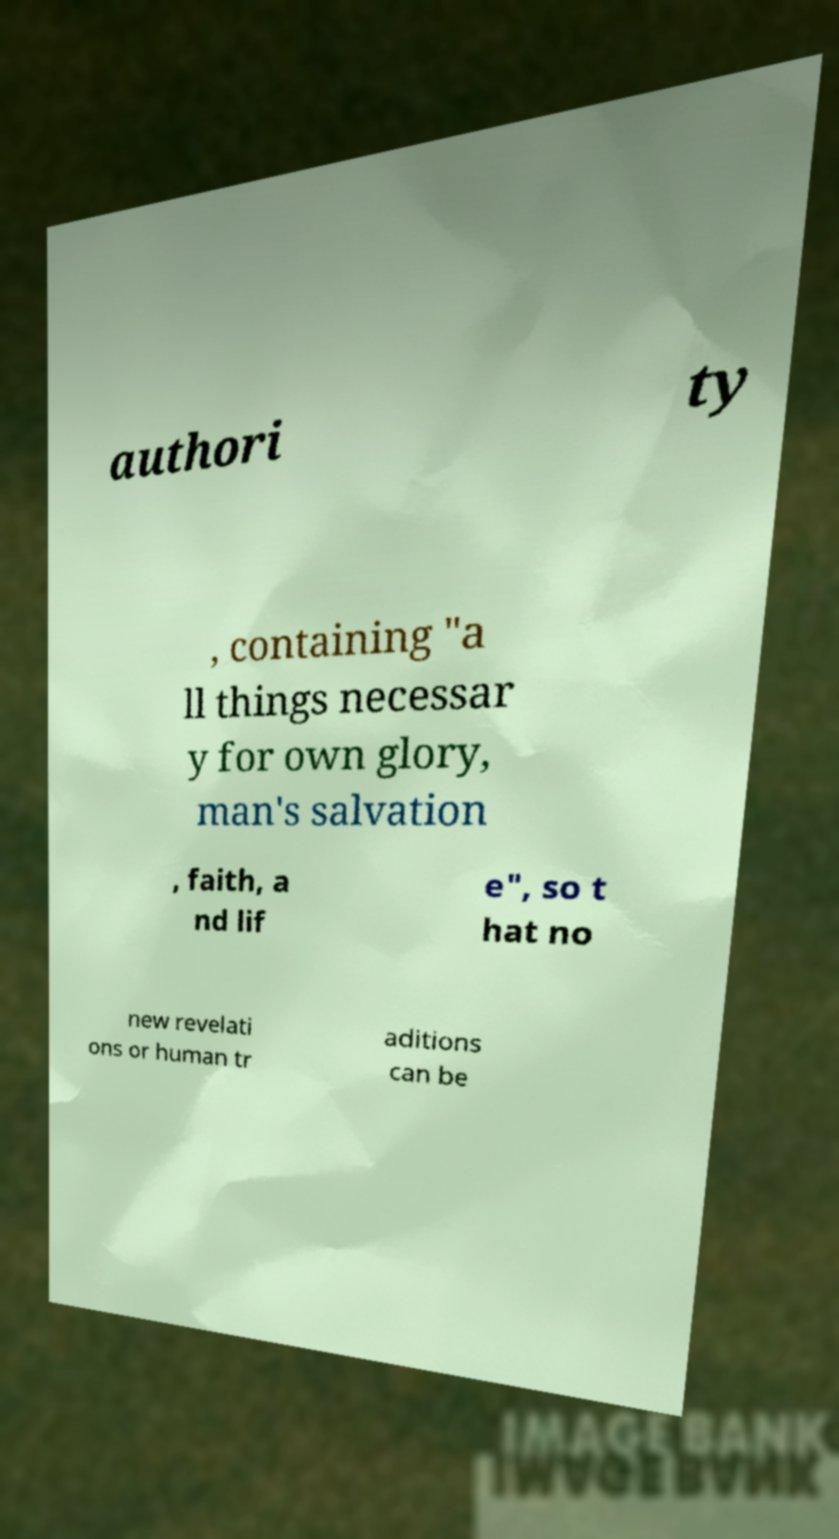Could you assist in decoding the text presented in this image and type it out clearly? authori ty , containing "a ll things necessar y for own glory, man's salvation , faith, a nd lif e", so t hat no new revelati ons or human tr aditions can be 